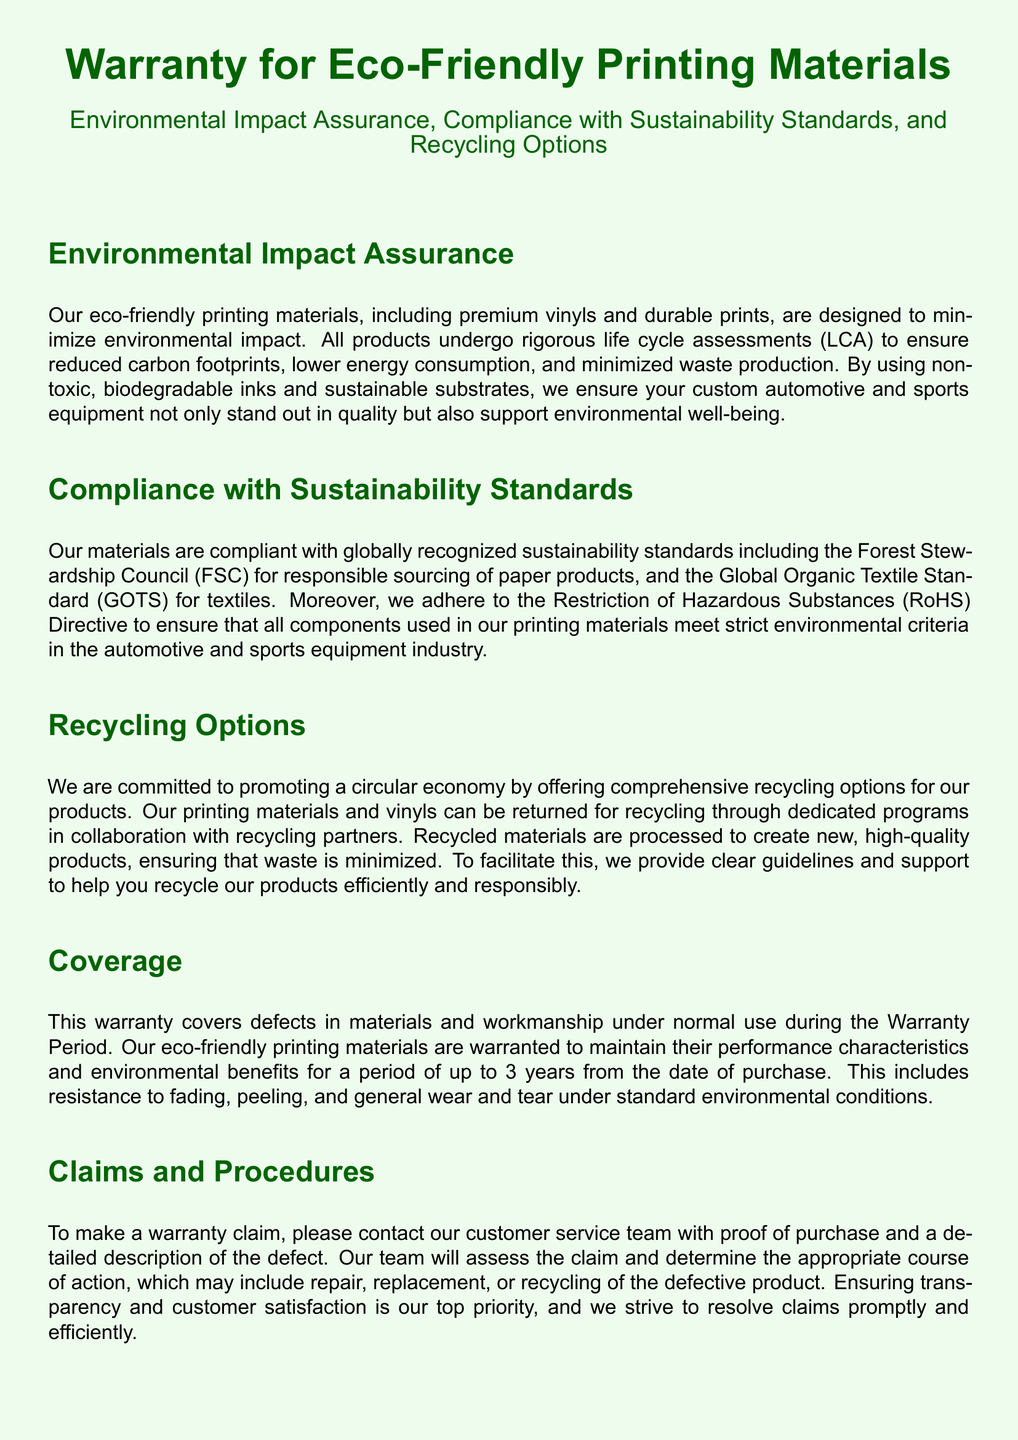What is the warranty period for eco-friendly printing materials? The warranty period for eco-friendly printing materials is specified in the coverage section of the document.
Answer: 3 years What types of inks are used in the printing materials? The document states that non-toxic, biodegradable inks are used in the eco-friendly printing materials.
Answer: Non-toxic, biodegradable inks Which sustainability standard is mentioned for responsible sourcing of paper products? The specific sustainability standard for responsible sourcing of paper products is included in the compliance section.
Answer: Forest Stewardship Council (FSC) What should a customer provide when making a warranty claim? The claims and procedures section outlines the necessary information needed for a warranty claim.
Answer: Proof of purchase and a detailed description of the defect Which directive ensures components used meet environmental criteria? The document refers to a specific directive that governs environmental criteria compliance in the materials used.
Answer: Restriction of Hazardous Substances (RoHS) Are there limitations on the warranty coverage? The limitations section specifies specific conditions under which the warranty does not apply.
Answer: Yes, there are limitations How long are recycled materials processed for new products? The document mentions the commitment to recycling but does not specify a duration for processing.
Answer: Not specified What type of warranty is this document describing? The document explicitly states the type of warranty offered.
Answer: Warranty for Eco-Friendly Printing Materials Where can customers contact for inquiries about the warranty? The contact information section provides details on where to direct inquiries.
Answer: support@example.com or 1-800-123-4567 